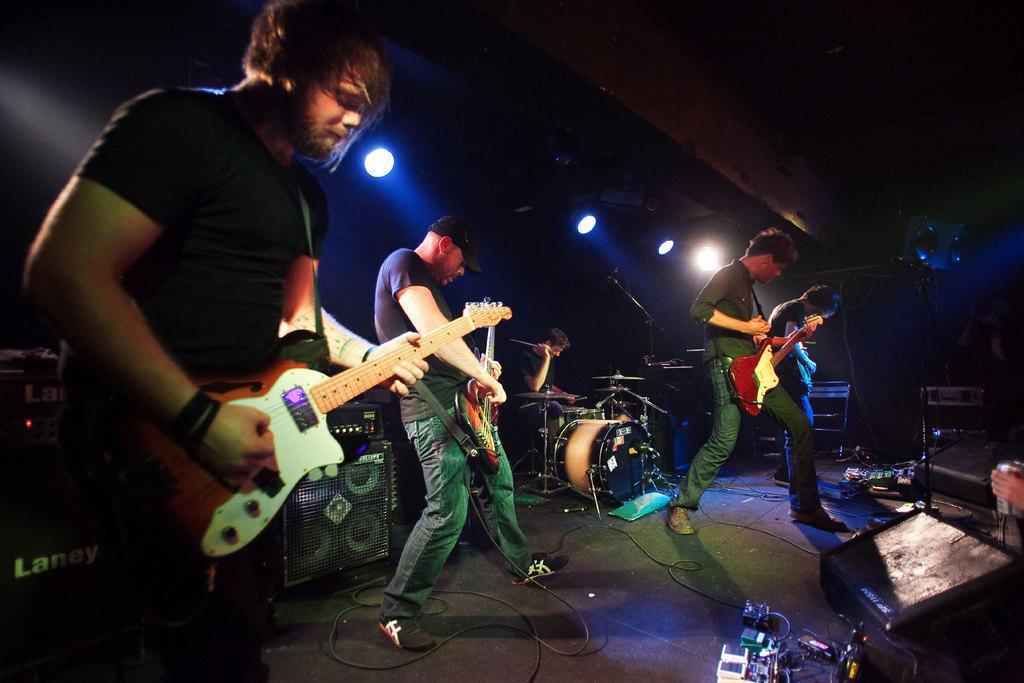How would you summarize this image in a sentence or two? In this picture we can see four men where they are holding guitars in their hands and playing it and at back of them one person sitting and playing drums and beside to them we have devices, wires, speakers and in background we can see light and it is dark. 